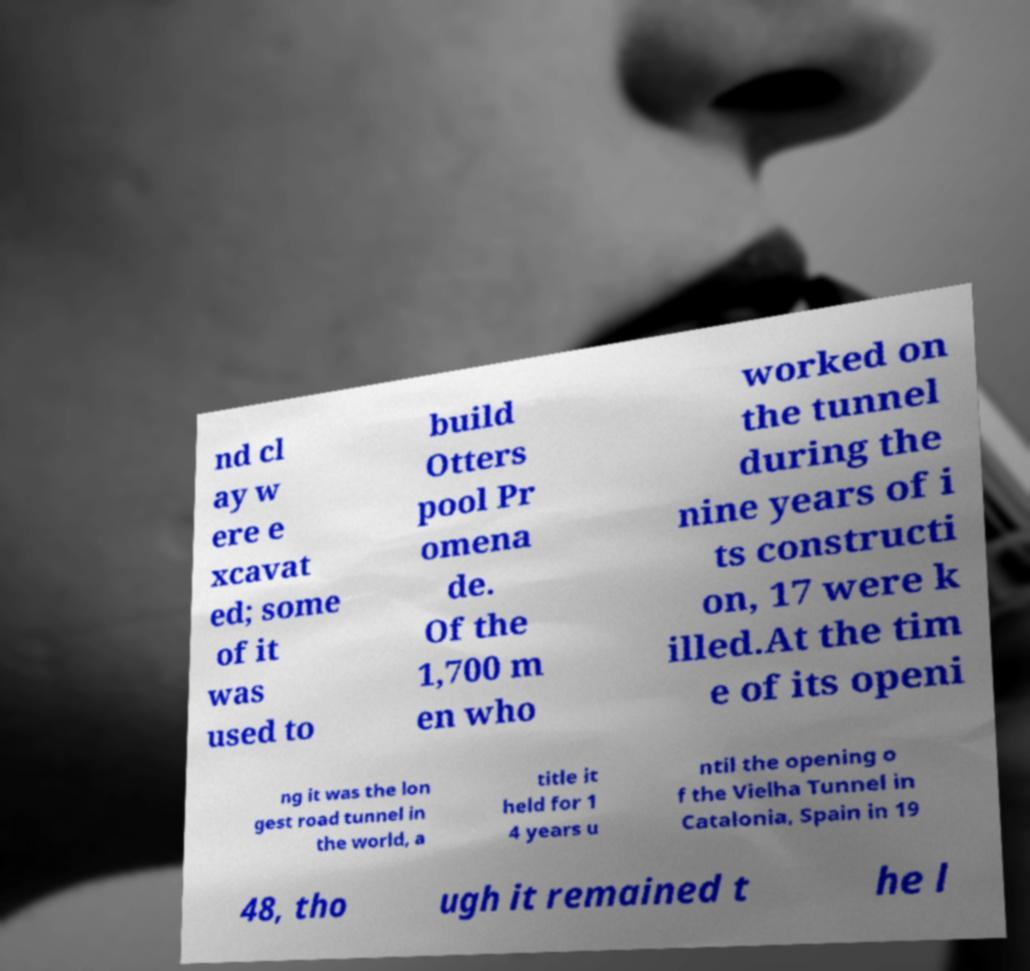Could you assist in decoding the text presented in this image and type it out clearly? nd cl ay w ere e xcavat ed; some of it was used to build Otters pool Pr omena de. Of the 1,700 m en who worked on the tunnel during the nine years of i ts constructi on, 17 were k illed.At the tim e of its openi ng it was the lon gest road tunnel in the world, a title it held for 1 4 years u ntil the opening o f the Vielha Tunnel in Catalonia, Spain in 19 48, tho ugh it remained t he l 